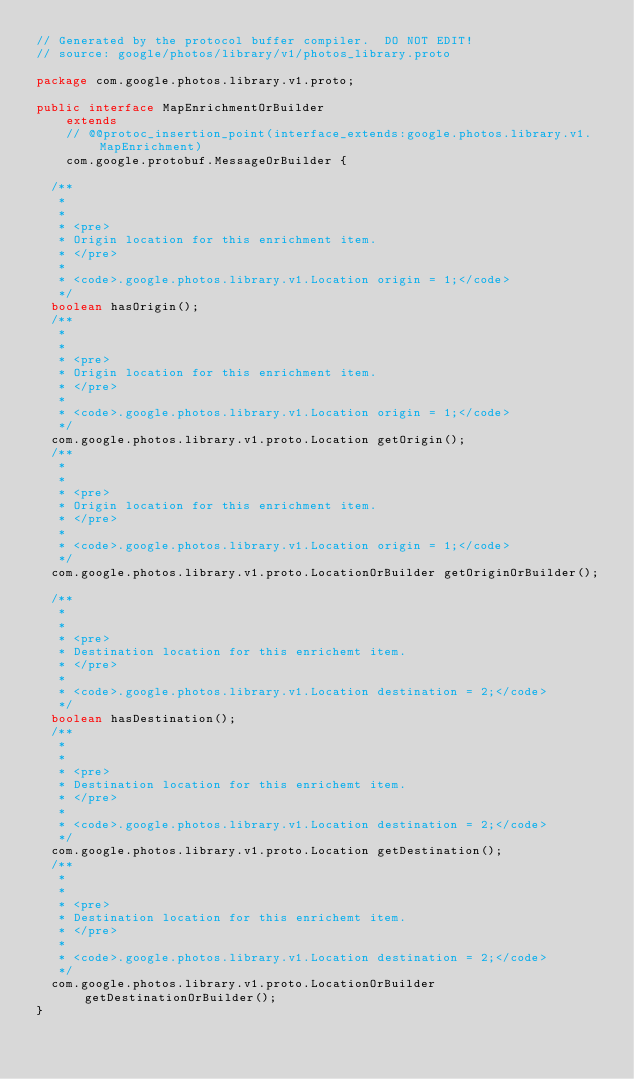Convert code to text. <code><loc_0><loc_0><loc_500><loc_500><_Java_>// Generated by the protocol buffer compiler.  DO NOT EDIT!
// source: google/photos/library/v1/photos_library.proto

package com.google.photos.library.v1.proto;

public interface MapEnrichmentOrBuilder
    extends
    // @@protoc_insertion_point(interface_extends:google.photos.library.v1.MapEnrichment)
    com.google.protobuf.MessageOrBuilder {

  /**
   *
   *
   * <pre>
   * Origin location for this enrichment item.
   * </pre>
   *
   * <code>.google.photos.library.v1.Location origin = 1;</code>
   */
  boolean hasOrigin();
  /**
   *
   *
   * <pre>
   * Origin location for this enrichment item.
   * </pre>
   *
   * <code>.google.photos.library.v1.Location origin = 1;</code>
   */
  com.google.photos.library.v1.proto.Location getOrigin();
  /**
   *
   *
   * <pre>
   * Origin location for this enrichment item.
   * </pre>
   *
   * <code>.google.photos.library.v1.Location origin = 1;</code>
   */
  com.google.photos.library.v1.proto.LocationOrBuilder getOriginOrBuilder();

  /**
   *
   *
   * <pre>
   * Destination location for this enrichemt item.
   * </pre>
   *
   * <code>.google.photos.library.v1.Location destination = 2;</code>
   */
  boolean hasDestination();
  /**
   *
   *
   * <pre>
   * Destination location for this enrichemt item.
   * </pre>
   *
   * <code>.google.photos.library.v1.Location destination = 2;</code>
   */
  com.google.photos.library.v1.proto.Location getDestination();
  /**
   *
   *
   * <pre>
   * Destination location for this enrichemt item.
   * </pre>
   *
   * <code>.google.photos.library.v1.Location destination = 2;</code>
   */
  com.google.photos.library.v1.proto.LocationOrBuilder getDestinationOrBuilder();
}
</code> 